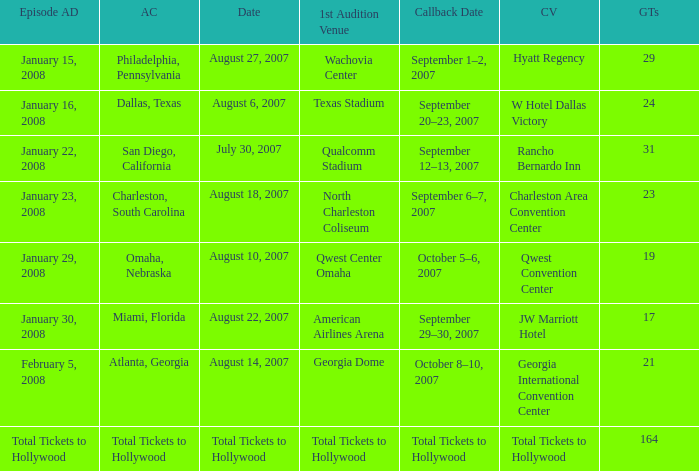What day has a callback Venue of total tickets to hollywood? Question Total Tickets to Hollywood. 